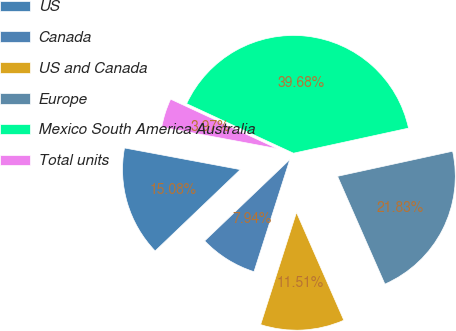<chart> <loc_0><loc_0><loc_500><loc_500><pie_chart><fcel>US<fcel>Canada<fcel>US and Canada<fcel>Europe<fcel>Mexico South America Australia<fcel>Total units<nl><fcel>15.08%<fcel>7.94%<fcel>11.51%<fcel>21.83%<fcel>39.68%<fcel>3.97%<nl></chart> 